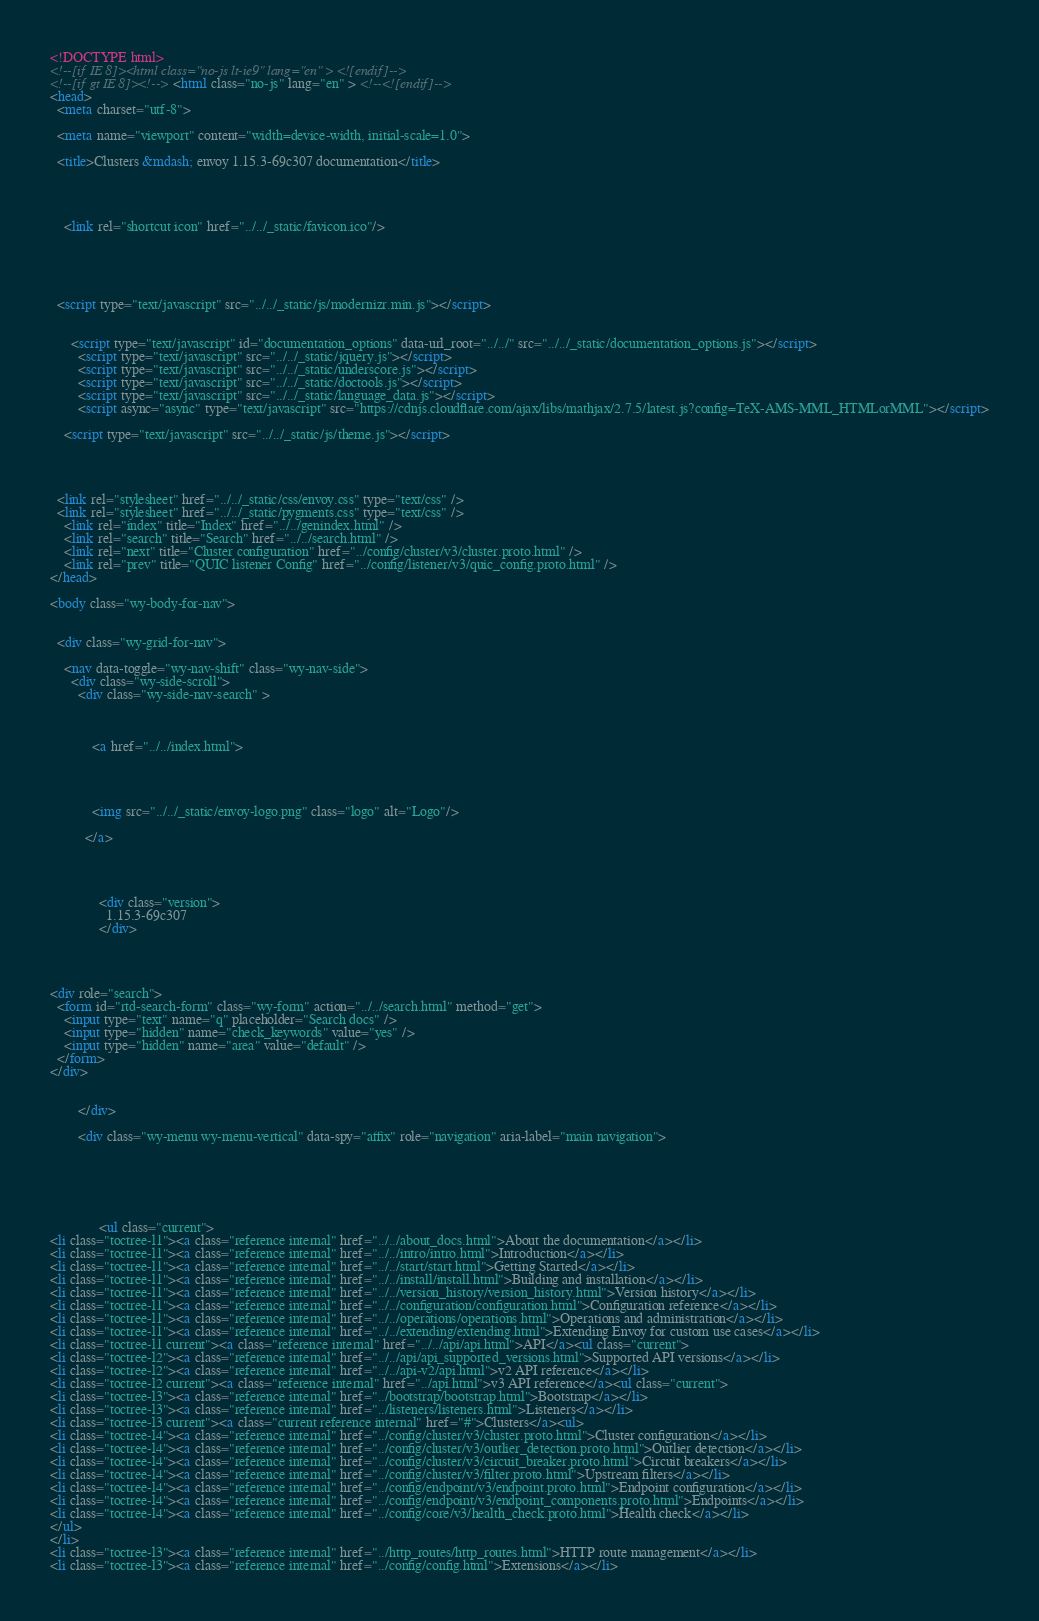<code> <loc_0><loc_0><loc_500><loc_500><_HTML_>

<!DOCTYPE html>
<!--[if IE 8]><html class="no-js lt-ie9" lang="en" > <![endif]-->
<!--[if gt IE 8]><!--> <html class="no-js" lang="en" > <!--<![endif]-->
<head>
  <meta charset="utf-8">
  
  <meta name="viewport" content="width=device-width, initial-scale=1.0">
  
  <title>Clusters &mdash; envoy 1.15.3-69c307 documentation</title>
  

  
  
    <link rel="shortcut icon" href="../../_static/favicon.ico"/>
  
  
  

  
  <script type="text/javascript" src="../../_static/js/modernizr.min.js"></script>
  
    
      <script type="text/javascript" id="documentation_options" data-url_root="../../" src="../../_static/documentation_options.js"></script>
        <script type="text/javascript" src="../../_static/jquery.js"></script>
        <script type="text/javascript" src="../../_static/underscore.js"></script>
        <script type="text/javascript" src="../../_static/doctools.js"></script>
        <script type="text/javascript" src="../../_static/language_data.js"></script>
        <script async="async" type="text/javascript" src="https://cdnjs.cloudflare.com/ajax/libs/mathjax/2.7.5/latest.js?config=TeX-AMS-MML_HTMLorMML"></script>
    
    <script type="text/javascript" src="../../_static/js/theme.js"></script>

    

  
  <link rel="stylesheet" href="../../_static/css/envoy.css" type="text/css" />
  <link rel="stylesheet" href="../../_static/pygments.css" type="text/css" />
    <link rel="index" title="Index" href="../../genindex.html" />
    <link rel="search" title="Search" href="../../search.html" />
    <link rel="next" title="Cluster configuration" href="../config/cluster/v3/cluster.proto.html" />
    <link rel="prev" title="QUIC listener Config" href="../config/listener/v3/quic_config.proto.html" /> 
</head>

<body class="wy-body-for-nav">

   
  <div class="wy-grid-for-nav">
    
    <nav data-toggle="wy-nav-shift" class="wy-nav-side">
      <div class="wy-side-scroll">
        <div class="wy-side-nav-search" >
          

          
            <a href="../../index.html">
          

          
            
            <img src="../../_static/envoy-logo.png" class="logo" alt="Logo"/>
          
          </a>

          
            
            
              <div class="version">
                1.15.3-69c307
              </div>
            
          

          
<div role="search">
  <form id="rtd-search-form" class="wy-form" action="../../search.html" method="get">
    <input type="text" name="q" placeholder="Search docs" />
    <input type="hidden" name="check_keywords" value="yes" />
    <input type="hidden" name="area" value="default" />
  </form>
</div>

          
        </div>

        <div class="wy-menu wy-menu-vertical" data-spy="affix" role="navigation" aria-label="main navigation">
          
            
            
              
            
            
              <ul class="current">
<li class="toctree-l1"><a class="reference internal" href="../../about_docs.html">About the documentation</a></li>
<li class="toctree-l1"><a class="reference internal" href="../../intro/intro.html">Introduction</a></li>
<li class="toctree-l1"><a class="reference internal" href="../../start/start.html">Getting Started</a></li>
<li class="toctree-l1"><a class="reference internal" href="../../install/install.html">Building and installation</a></li>
<li class="toctree-l1"><a class="reference internal" href="../../version_history/version_history.html">Version history</a></li>
<li class="toctree-l1"><a class="reference internal" href="../../configuration/configuration.html">Configuration reference</a></li>
<li class="toctree-l1"><a class="reference internal" href="../../operations/operations.html">Operations and administration</a></li>
<li class="toctree-l1"><a class="reference internal" href="../../extending/extending.html">Extending Envoy for custom use cases</a></li>
<li class="toctree-l1 current"><a class="reference internal" href="../../api/api.html">API</a><ul class="current">
<li class="toctree-l2"><a class="reference internal" href="../../api/api_supported_versions.html">Supported API versions</a></li>
<li class="toctree-l2"><a class="reference internal" href="../../api-v2/api.html">v2 API reference</a></li>
<li class="toctree-l2 current"><a class="reference internal" href="../api.html">v3 API reference</a><ul class="current">
<li class="toctree-l3"><a class="reference internal" href="../bootstrap/bootstrap.html">Bootstrap</a></li>
<li class="toctree-l3"><a class="reference internal" href="../listeners/listeners.html">Listeners</a></li>
<li class="toctree-l3 current"><a class="current reference internal" href="#">Clusters</a><ul>
<li class="toctree-l4"><a class="reference internal" href="../config/cluster/v3/cluster.proto.html">Cluster configuration</a></li>
<li class="toctree-l4"><a class="reference internal" href="../config/cluster/v3/outlier_detection.proto.html">Outlier detection</a></li>
<li class="toctree-l4"><a class="reference internal" href="../config/cluster/v3/circuit_breaker.proto.html">Circuit breakers</a></li>
<li class="toctree-l4"><a class="reference internal" href="../config/cluster/v3/filter.proto.html">Upstream filters</a></li>
<li class="toctree-l4"><a class="reference internal" href="../config/endpoint/v3/endpoint.proto.html">Endpoint configuration</a></li>
<li class="toctree-l4"><a class="reference internal" href="../config/endpoint/v3/endpoint_components.proto.html">Endpoints</a></li>
<li class="toctree-l4"><a class="reference internal" href="../config/core/v3/health_check.proto.html">Health check</a></li>
</ul>
</li>
<li class="toctree-l3"><a class="reference internal" href="../http_routes/http_routes.html">HTTP route management</a></li>
<li class="toctree-l3"><a class="reference internal" href="../config/config.html">Extensions</a></li></code> 